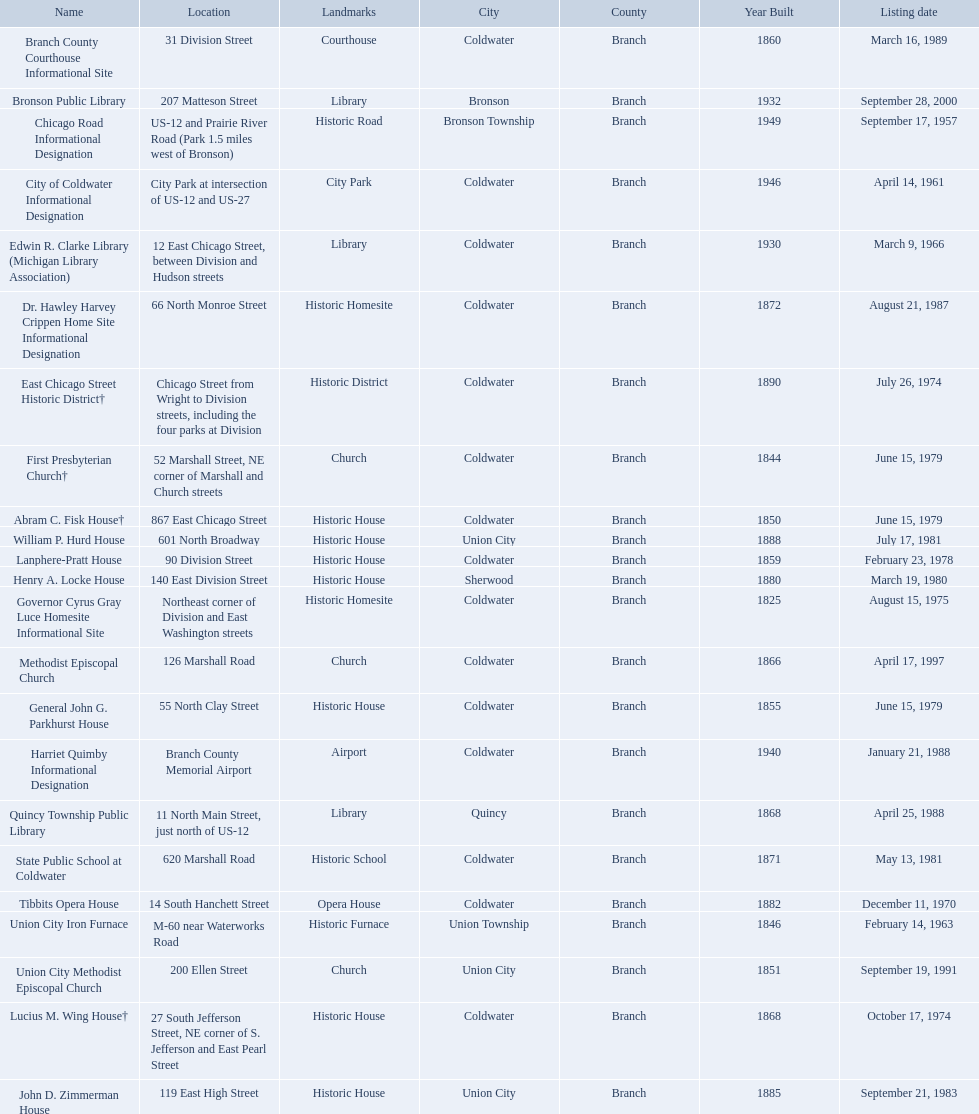What are all of the locations considered historical sites in branch county, michigan? Branch County Courthouse Informational Site, Bronson Public Library, Chicago Road Informational Designation, City of Coldwater Informational Designation, Edwin R. Clarke Library (Michigan Library Association), Dr. Hawley Harvey Crippen Home Site Informational Designation, East Chicago Street Historic District†, First Presbyterian Church†, Abram C. Fisk House†, William P. Hurd House, Lanphere-Pratt House, Henry A. Locke House, Governor Cyrus Gray Luce Homesite Informational Site, Methodist Episcopal Church, General John G. Parkhurst House, Harriet Quimby Informational Designation, Quincy Township Public Library, State Public School at Coldwater, Tibbits Opera House, Union City Iron Furnace, Union City Methodist Episcopal Church, Lucius M. Wing House†, John D. Zimmerman House. Of those sites, which one was the first to be listed as historical? Chicago Road Informational Designation. Are there any listing dates that happened before 1960? September 17, 1957. What is the name of the site that was listed before 1960? Chicago Road Informational Designation. 